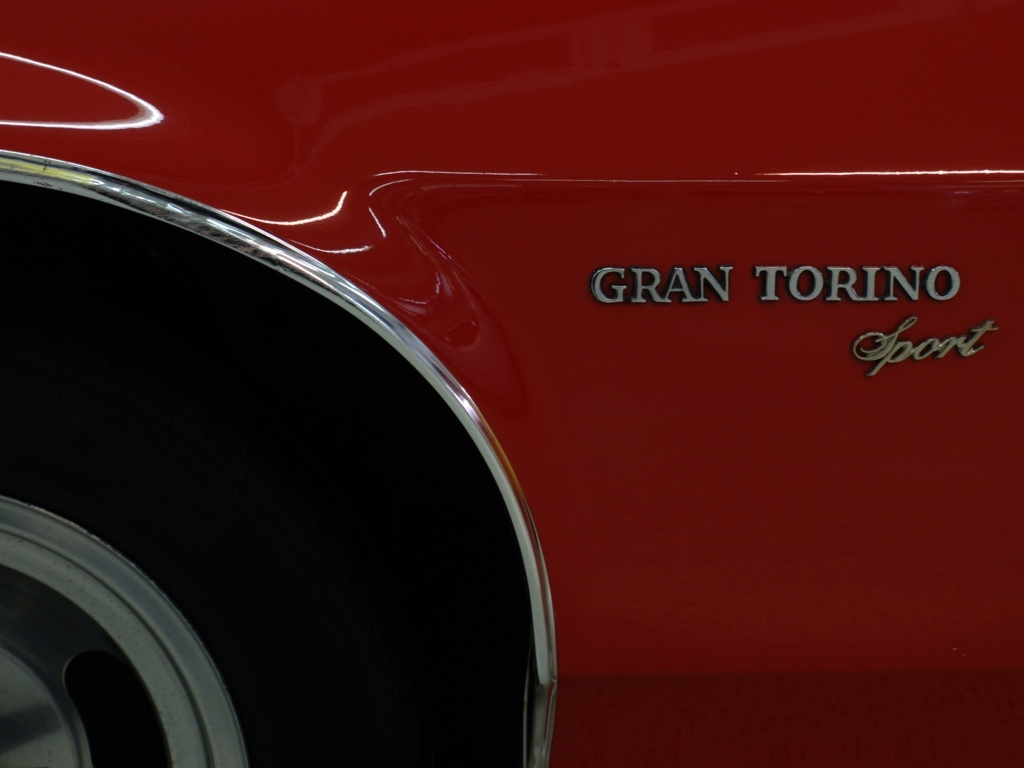Explain the significance of the vehicle's name to car enthusiasts. The Ford Gran Torino has earned a place in American car culture due to its iconic design and association with the era's muscle car identity. It has also been featured in various forms of media, which has elevated its status among collectors and enthusiasts. The 'Sport' badge denotes a performance-oriented trim level, which adds to its desirability. 